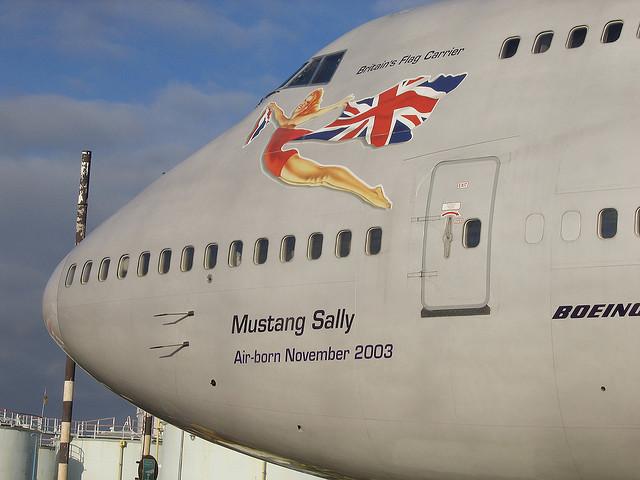What country does it fly to?
Quick response, please. Great britain. How long has it been in service?
Write a very short answer. 2003. What is the name of the plane?
Write a very short answer. Mustang sally. 